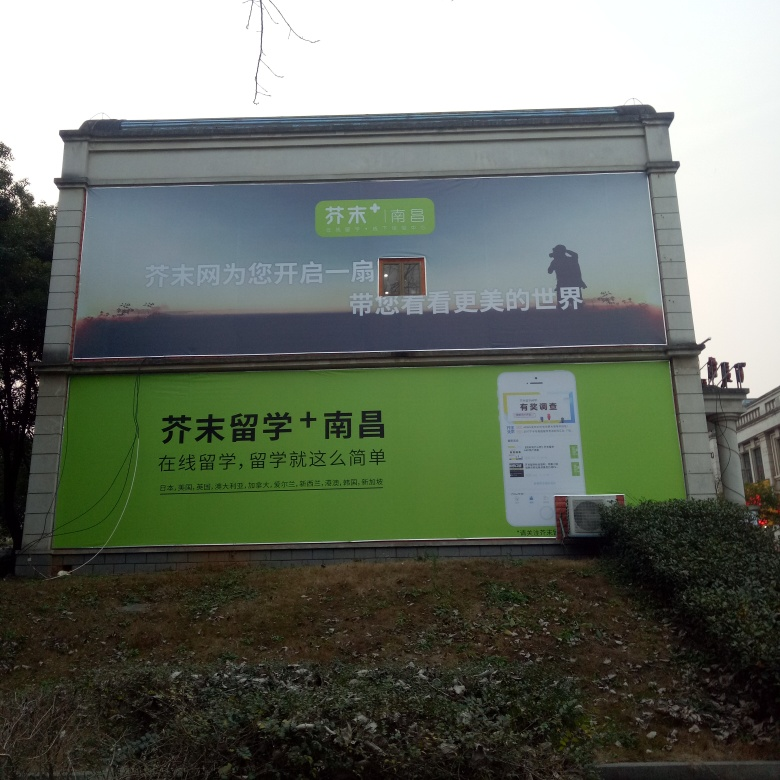What does the text on the billboard say? The billboard features promotional content for a mobile application. The text discusses benefits and features related to the app, encouraging viewers to download and use it. 